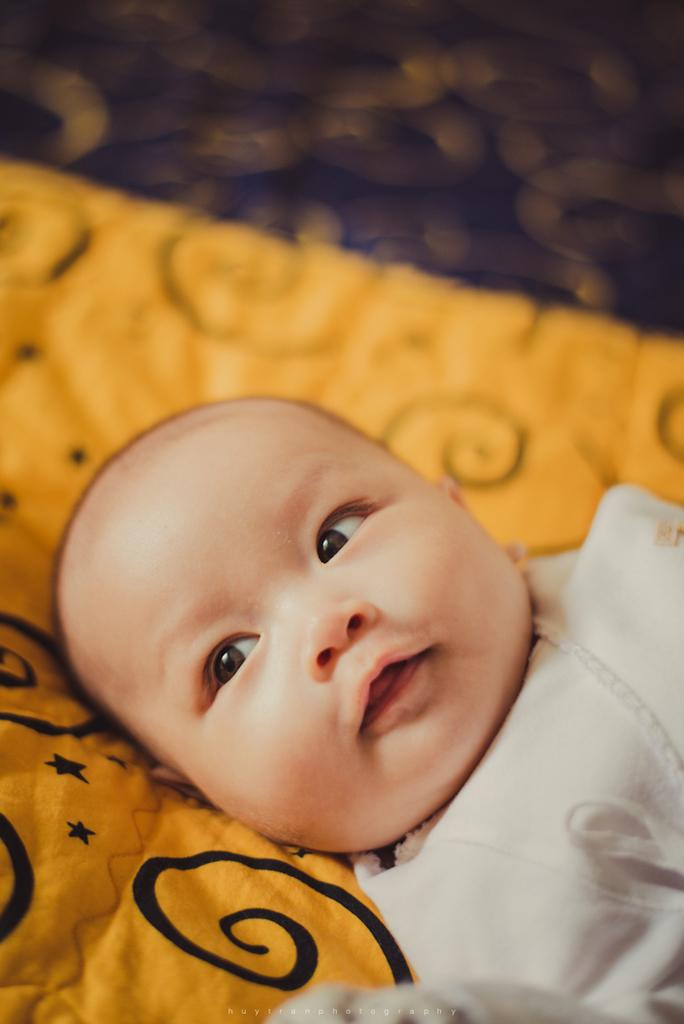What is the main subject of the image? There is a baby in the image. What is the baby laying on? The baby is laying on a yellow color blanket. What is the baby wearing? The baby is wearing a white color dress. What letters can be seen in the image? There are no letters visible in the image; it features a baby laying on a yellow color blanket and wearing a white color dress. 